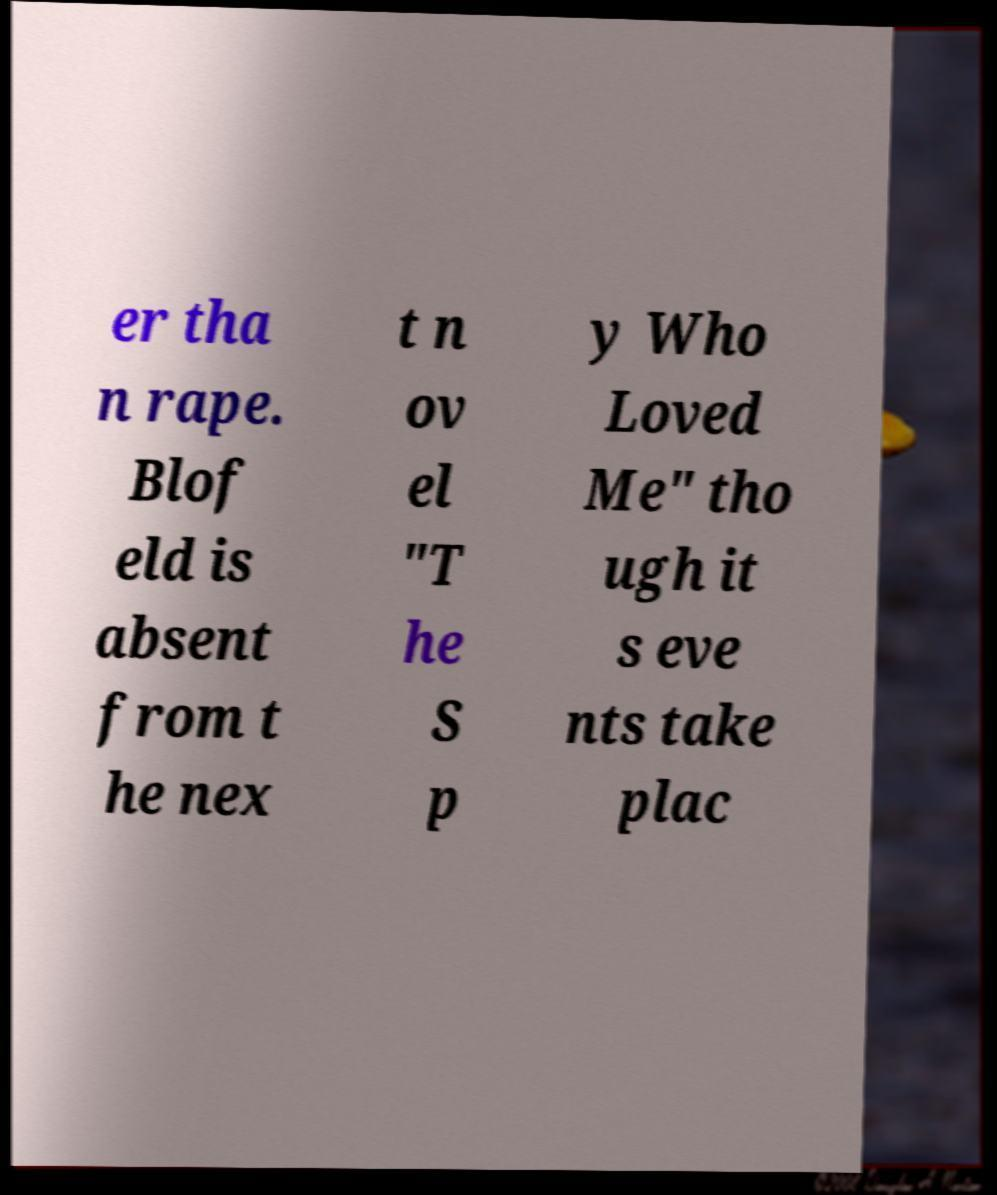Please read and relay the text visible in this image. What does it say? er tha n rape. Blof eld is absent from t he nex t n ov el "T he S p y Who Loved Me" tho ugh it s eve nts take plac 